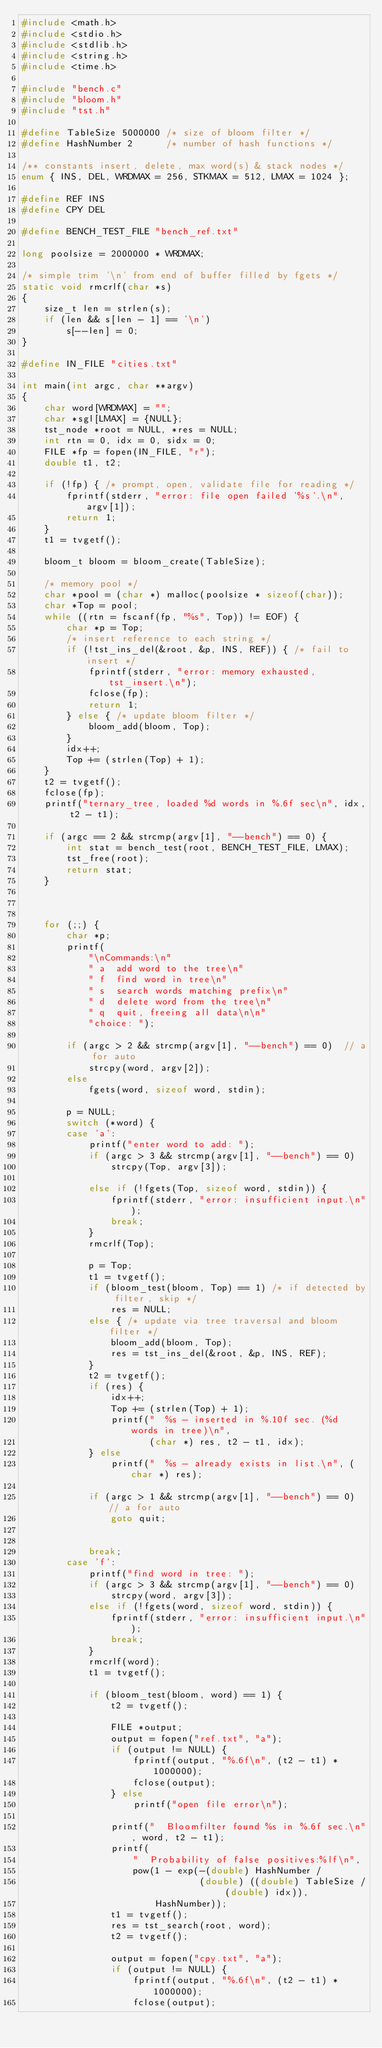<code> <loc_0><loc_0><loc_500><loc_500><_C_>#include <math.h>
#include <stdio.h>
#include <stdlib.h>
#include <string.h>
#include <time.h>

#include "bench.c"
#include "bloom.h"
#include "tst.h"

#define TableSize 5000000 /* size of bloom filter */
#define HashNumber 2      /* number of hash functions */

/** constants insert, delete, max word(s) & stack nodes */
enum { INS, DEL, WRDMAX = 256, STKMAX = 512, LMAX = 1024 };

#define REF INS
#define CPY DEL

#define BENCH_TEST_FILE "bench_ref.txt"

long poolsize = 2000000 * WRDMAX;

/* simple trim '\n' from end of buffer filled by fgets */
static void rmcrlf(char *s)
{
    size_t len = strlen(s);
    if (len && s[len - 1] == '\n')
        s[--len] = 0;
}

#define IN_FILE "cities.txt"

int main(int argc, char **argv)
{
    char word[WRDMAX] = "";
    char *sgl[LMAX] = {NULL};
    tst_node *root = NULL, *res = NULL;
    int rtn = 0, idx = 0, sidx = 0;
    FILE *fp = fopen(IN_FILE, "r");
    double t1, t2;

    if (!fp) { /* prompt, open, validate file for reading */
        fprintf(stderr, "error: file open failed '%s'.\n", argv[1]);
        return 1;
    }
    t1 = tvgetf();

    bloom_t bloom = bloom_create(TableSize);

    /* memory pool */
    char *pool = (char *) malloc(poolsize * sizeof(char));
    char *Top = pool;
    while ((rtn = fscanf(fp, "%s", Top)) != EOF) {
        char *p = Top;
        /* insert reference to each string */
        if (!tst_ins_del(&root, &p, INS, REF)) { /* fail to insert */
            fprintf(stderr, "error: memory exhausted, tst_insert.\n");
            fclose(fp);
            return 1;
        } else { /* update bloom filter */
            bloom_add(bloom, Top);
        }
        idx++;
        Top += (strlen(Top) + 1);
    }
    t2 = tvgetf();
    fclose(fp);
    printf("ternary_tree, loaded %d words in %.6f sec\n", idx, t2 - t1);

    if (argc == 2 && strcmp(argv[1], "--bench") == 0) {
        int stat = bench_test(root, BENCH_TEST_FILE, LMAX);
        tst_free(root);
        return stat;
    }



    for (;;) {
        char *p;
        printf(
            "\nCommands:\n"
            " a  add word to the tree\n"
            " f  find word in tree\n"
            " s  search words matching prefix\n"
            " d  delete word from the tree\n"
            " q  quit, freeing all data\n\n"
            "choice: ");

        if (argc > 2 && strcmp(argv[1], "--bench") == 0)  // a for auto
            strcpy(word, argv[2]);
        else
            fgets(word, sizeof word, stdin);

        p = NULL;
        switch (*word) {
        case 'a':
            printf("enter word to add: ");
            if (argc > 3 && strcmp(argv[1], "--bench") == 0)
                strcpy(Top, argv[3]);

            else if (!fgets(Top, sizeof word, stdin)) {
                fprintf(stderr, "error: insufficient input.\n");
                break;
            }
            rmcrlf(Top);

            p = Top;
            t1 = tvgetf();
            if (bloom_test(bloom, Top) == 1) /* if detected by filter, skip */
                res = NULL;
            else { /* update via tree traversal and bloom filter */
                bloom_add(bloom, Top);
                res = tst_ins_del(&root, &p, INS, REF);
            }
            t2 = tvgetf();
            if (res) {
                idx++;
                Top += (strlen(Top) + 1);
                printf("  %s - inserted in %.10f sec. (%d words in tree)\n",
                       (char *) res, t2 - t1, idx);
            } else
                printf("  %s - already exists in list.\n", (char *) res);

            if (argc > 1 && strcmp(argv[1], "--bench") == 0)  // a for auto
                goto quit;


            break;
        case 'f':
            printf("find word in tree: ");
            if (argc > 3 && strcmp(argv[1], "--bench") == 0)
                strcpy(word, argv[3]);
            else if (!fgets(word, sizeof word, stdin)) {
                fprintf(stderr, "error: insufficient input.\n");
                break;
            }
            rmcrlf(word);
            t1 = tvgetf();

            if (bloom_test(bloom, word) == 1) {
                t2 = tvgetf();

                FILE *output;
                output = fopen("ref.txt", "a");
                if (output != NULL) {
                    fprintf(output, "%.6f\n", (t2 - t1) * 1000000);
                    fclose(output);
                } else
                    printf("open file error\n");

                printf("  Bloomfilter found %s in %.6f sec.\n", word, t2 - t1);
                printf(
                    "  Probability of false positives:%lf\n",
                    pow(1 - exp(-(double) HashNumber /
                                (double) ((double) TableSize / (double) idx)),
                        HashNumber));
                t1 = tvgetf();
                res = tst_search(root, word);
                t2 = tvgetf();

                output = fopen("cpy.txt", "a");
                if (output != NULL) {
                    fprintf(output, "%.6f\n", (t2 - t1) * 1000000);
                    fclose(output);</code> 